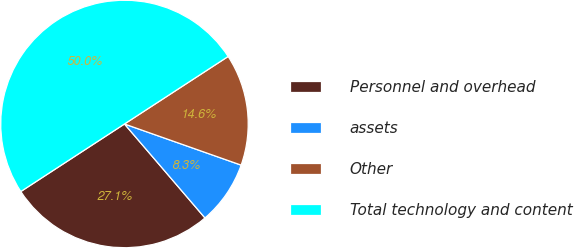Convert chart to OTSL. <chart><loc_0><loc_0><loc_500><loc_500><pie_chart><fcel>Personnel and overhead<fcel>assets<fcel>Other<fcel>Total technology and content<nl><fcel>27.08%<fcel>8.33%<fcel>14.58%<fcel>50.0%<nl></chart> 